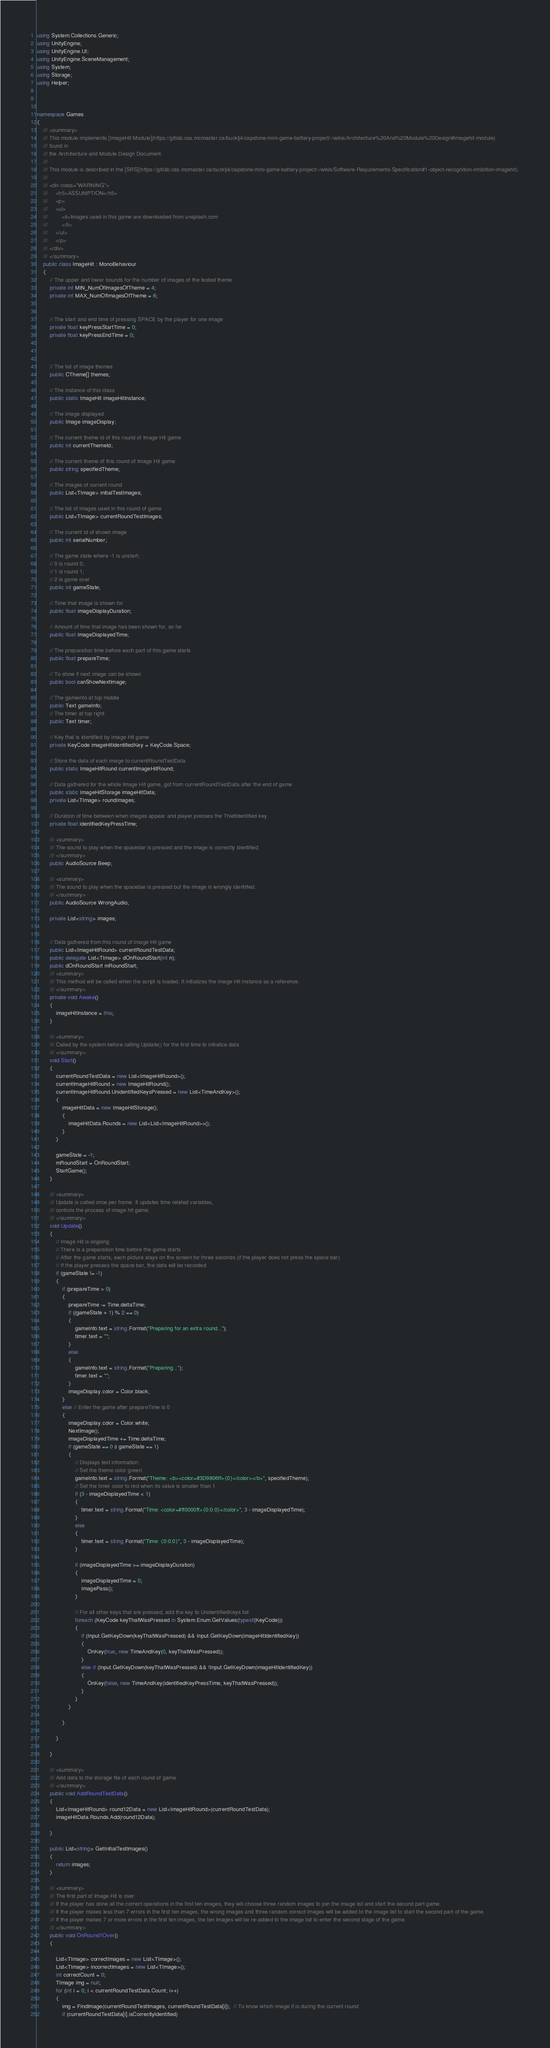Convert code to text. <code><loc_0><loc_0><loc_500><loc_500><_C#_>using System.Collections.Generic;
using UnityEngine;
using UnityEngine.UI;
using UnityEngine.SceneManagement;
using System;
using Storage;
using Helper;



namespace Games
{
    /// <summary>
    /// This module implements [ImageHit Module](https://gitlab.cas.mcmaster.ca/bucklj4/capstone-mini-game-battery-project/-/wikis/Architecture%20And%20Module%20Design#imagehit-module)
    /// found in
    /// the Architecture and Module Design Document.
    /// 
    /// This module is described in the [SRS](https://gitlab.cas.mcmaster.ca/bucklj4/capstone-mini-game-battery-project/-/wikis/Software-Requirements-Specification#1-object-recognition-inhibition-imagehit).
    ///
    /// <div class="WARNING">
    ///     <h5>ASSUMPTION</h5>
    ///     <p>
    ///     <ul>
    ///         <li>Images used in this game are downloaded from unsplash.com
    ///         </li>
    ///     </ul>
    ///     </p>
    /// </div>
    /// </summary>
    public class ImageHit : MonoBehaviour
    {
        // The upper and lower bounds for the number of images of the tested theme 
        private int MIN_NumOfImagesOfTheme = 4;
        private int MAX_NumOfImagesOfTheme = 6;


        // The start and end time of pressing SPACE by the player for one image
        private float keyPressStartTime = 0;
        private float keyPressEndTime = 0;



        // The list of image themes
        public CTheme[] themes;

        // The instance of this class
        public static ImageHit imageHitInstance;

        // The image displayed
        public Image imageDisplay;

        // The current theme id of this round of Image Hit game
        public int currentThemeId;

        // The current theme of this round of Image Hit game
        public string specifiedTheme;

        // The images of current round
        public List<TImage> initialTestImages;

        // The list of images used in this round of game
        public List<TImage> currentRoundTestImages;

        // The current id of shown image
        public int serialNumber;

        // The game state where -1 is unstart;
        // 0 is round 0;
        // 1 is round 1;
        // 2 is game over
        public int gameState;

        // Time that image is shown for
        public float imageDisplayDuration;

        // Amount of time that image has been shown for, so far
        public float imageDisplayedTime;

        // The preparation time before each part of this game starts
        public float prepareTime;

        // To show if next image can be shown
        public bool canShowNextImage;

        // The gameinfo at top middle
        public Text gameInfo;
        // The timer at top right
        public Text timer;

        // Key that is identified by Image Hit game
        private KeyCode imageHitIdentifiedKey = KeyCode.Space;

        // Store the data of each image to currentRoundTestData
        public static ImageHitRound currentImageHitRound;

        // Data gathered for the whole Image Hit game, got from currentRoundTestData after the end of game
        public static ImageHitStorage imageHitData;
        private List<TImage> roundImages;

        // Duration of time between when images appear and player presses the ThiefIdentified key
        private float identifiedKeyPressTime;

        /// <summary>
        /// The sound to play when the spacebar is pressed and the image is correctly identified.
        /// </summary>
        public AudioSource Beep;

        /// <summary>
        /// The sound to play when the spacebar is pressed but the image is wrongly identified.
        /// </summary>
        public AudioSource WrongAudio;

        private List<string> images;


        // Data gathered from this round of Image Hit game
        public List<ImageHitRound> currentRoundTestData;
        public delegate List<TImage> dOnRoundStart(int n);
        public dOnRoundStart mRoundStart;
        /// <summary>
        /// This method will be called when the script is loaded. It initializes the image Hit instance as a reference.
        /// </summary>
        private void Awake()
        {
            imageHitInstance = this;
        }

        /// <summary>
        /// Called by the system before calling Update() for the first time to initialize data
        /// </summary>
        void Start()
        {
            currentRoundTestData = new List<ImageHitRound>();
            currentImageHitRound = new ImageHitRound();
            currentImageHitRound.UnidentifiedKeysPressed = new List<TimeAndKey>();
            {
                imageHitData = new ImageHitStorage();
                {
                    imageHitData.Rounds = new List<List<ImageHitRound>>();
                }
            }

            gameState = -1;
            mRoundStart = OnRoundStart;
            StartGame();
        }

        /// <summary>
        /// Update is called once per frame. It updates time related variables,
        /// controls the process of image hit game.
        /// </summary>
        void Update()
        {
            // Image Hit is ongoing
            // There is a preparation time before the game starts
            // After the game starts, each picture stays on the screen for three seconds (if the player does not press the space bar)
            // If the player presses the space bar, the data will be recorded
            if (gameState != -1)
            {
                if (prepareTime > 0)
                {
                    prepareTime -= Time.deltaTime;
                    if ((gameState + 1) % 2 == 0)
                    {
                        gameInfo.text = string.Format("Preparing for an extra round...");
                        timer.text = "";
                    }
                    else
                    {
                        gameInfo.text = string.Format("Preparing...");
                        timer.text = "";
                    }
                    imageDisplay.color = Color.black;
                }
                else // Enter the game after prepareTime is 0
                {
                    imageDisplay.color = Color.white;
                    NextImage();
                    imageDisplayedTime += Time.deltaTime;
                    if (gameState == 0 || gameState == 1)
                    {
                        // Displays text information:
                        // Set the theme color green
                        gameInfo.text = string.Format("Theme: <b><color=#3D9806ff>{0}</color></b>", specifiedTheme);
                        // Set the timer color to red when its value is smaller than 1
                        if (3 - imageDisplayedTime < 1)
                        {
                            timer.text = string.Format("Time: <color=#ff0000ff>{0:0.0}</color>", 3 - imageDisplayedTime);
                        }
                        else
                        {
                            timer.text = string.Format("Time: {0:0.0}", 3 - imageDisplayedTime);
                        }

                        if (imageDisplayedTime >= imageDisplayDuration)
                        {
                            imageDisplayedTime = 0;
                            ImagePass();
                        }

                        // For all other keys that are pressed, add the key to UnidentifiedKeys list
                        foreach (KeyCode keyThatWasPressed in System.Enum.GetValues(typeof(KeyCode)))
                        {
                            if (Input.GetKeyDown(keyThatWasPressed) && Input.GetKeyDown(imageHitIdentifiedKey))
                            {
                                OnKey(true, new TimeAndKey(0, keyThatWasPressed));
                            }
                            else if (Input.GetKeyDown(keyThatWasPressed) && !Input.GetKeyDown(imageHitIdentifiedKey))
                            {
                                OnKey(false, new TimeAndKey(identifiedKeyPressTime, keyThatWasPressed));
                            }
                        }
                    }

                }

            }

        }

        /// <summary>
        /// Add data to the storage file of each round of game
        /// </summary>
        public void AddRoundTestData()
        {
            List<ImageHitRound> round12Data = new List<ImageHitRound>(currentRoundTestData);
            imageHitData.Rounds.Add(round12Data);

        }

        public List<string> GetInitialTestImages()
        {
            return images;
        }

        /// <summary>
        /// The first part of Image Hit is over
        /// If the player has done all the correct operations in the first ten images, they will choose three random images to join the image list and start the second part game.
        /// If the player makes less than 7 errors in the first ten images, the wrong images and three random correct images will be added to the image list to start the second part of the game.
        /// If the player makes 7 or more errors in the first ten images, the ten images will be re-added to the image list to enter the second stage of the game.
        /// </summary>
        public void OnRound1Over()
        {

            List<TImage> correctImages = new List<TImage>();
            List<TImage> incorrectImages = new List<TImage>();
            int correctCount = 0;
            TImage img = null;
            for (int i = 0; i < currentRoundTestData.Count; i++)
            {
                img = FindImage(currentRoundTestImages, currentRoundTestData[i]);  // To know which image it is during the current round
                if (currentRoundTestData[i].isCorrectlyIdentified)</code> 